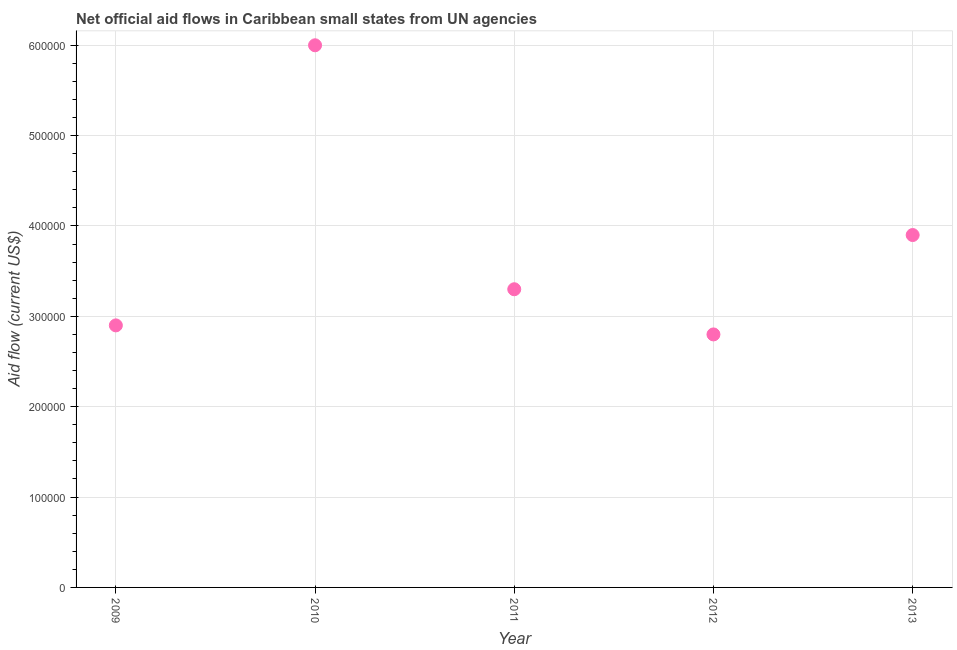What is the net official flows from un agencies in 2012?
Make the answer very short. 2.80e+05. Across all years, what is the maximum net official flows from un agencies?
Your answer should be compact. 6.00e+05. Across all years, what is the minimum net official flows from un agencies?
Give a very brief answer. 2.80e+05. In which year was the net official flows from un agencies maximum?
Offer a very short reply. 2010. What is the sum of the net official flows from un agencies?
Your answer should be compact. 1.89e+06. What is the difference between the net official flows from un agencies in 2011 and 2013?
Provide a succinct answer. -6.00e+04. What is the average net official flows from un agencies per year?
Your answer should be compact. 3.78e+05. What is the median net official flows from un agencies?
Your response must be concise. 3.30e+05. What is the ratio of the net official flows from un agencies in 2010 to that in 2012?
Your answer should be very brief. 2.14. Is the net official flows from un agencies in 2010 less than that in 2011?
Offer a terse response. No. Is the difference between the net official flows from un agencies in 2009 and 2012 greater than the difference between any two years?
Your answer should be very brief. No. What is the difference between the highest and the lowest net official flows from un agencies?
Make the answer very short. 3.20e+05. How many dotlines are there?
Provide a short and direct response. 1. What is the difference between two consecutive major ticks on the Y-axis?
Keep it short and to the point. 1.00e+05. Does the graph contain any zero values?
Keep it short and to the point. No. What is the title of the graph?
Your response must be concise. Net official aid flows in Caribbean small states from UN agencies. What is the label or title of the X-axis?
Provide a succinct answer. Year. What is the Aid flow (current US$) in 2010?
Your response must be concise. 6.00e+05. What is the Aid flow (current US$) in 2011?
Your response must be concise. 3.30e+05. What is the Aid flow (current US$) in 2012?
Offer a very short reply. 2.80e+05. What is the difference between the Aid flow (current US$) in 2009 and 2010?
Your response must be concise. -3.10e+05. What is the difference between the Aid flow (current US$) in 2009 and 2012?
Your answer should be compact. 10000. What is the difference between the Aid flow (current US$) in 2011 and 2013?
Provide a succinct answer. -6.00e+04. What is the ratio of the Aid flow (current US$) in 2009 to that in 2010?
Provide a short and direct response. 0.48. What is the ratio of the Aid flow (current US$) in 2009 to that in 2011?
Provide a short and direct response. 0.88. What is the ratio of the Aid flow (current US$) in 2009 to that in 2012?
Ensure brevity in your answer.  1.04. What is the ratio of the Aid flow (current US$) in 2009 to that in 2013?
Your response must be concise. 0.74. What is the ratio of the Aid flow (current US$) in 2010 to that in 2011?
Your answer should be very brief. 1.82. What is the ratio of the Aid flow (current US$) in 2010 to that in 2012?
Provide a short and direct response. 2.14. What is the ratio of the Aid flow (current US$) in 2010 to that in 2013?
Provide a succinct answer. 1.54. What is the ratio of the Aid flow (current US$) in 2011 to that in 2012?
Give a very brief answer. 1.18. What is the ratio of the Aid flow (current US$) in 2011 to that in 2013?
Offer a very short reply. 0.85. What is the ratio of the Aid flow (current US$) in 2012 to that in 2013?
Your answer should be compact. 0.72. 